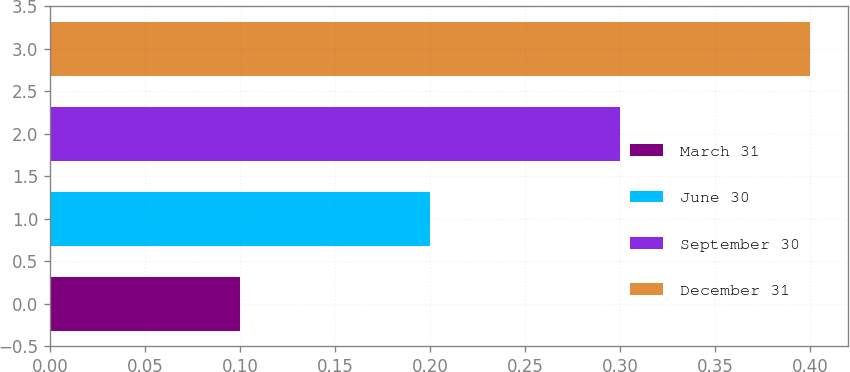<chart> <loc_0><loc_0><loc_500><loc_500><bar_chart><fcel>March 31<fcel>June 30<fcel>September 30<fcel>December 31<nl><fcel>0.1<fcel>0.2<fcel>0.3<fcel>0.4<nl></chart> 